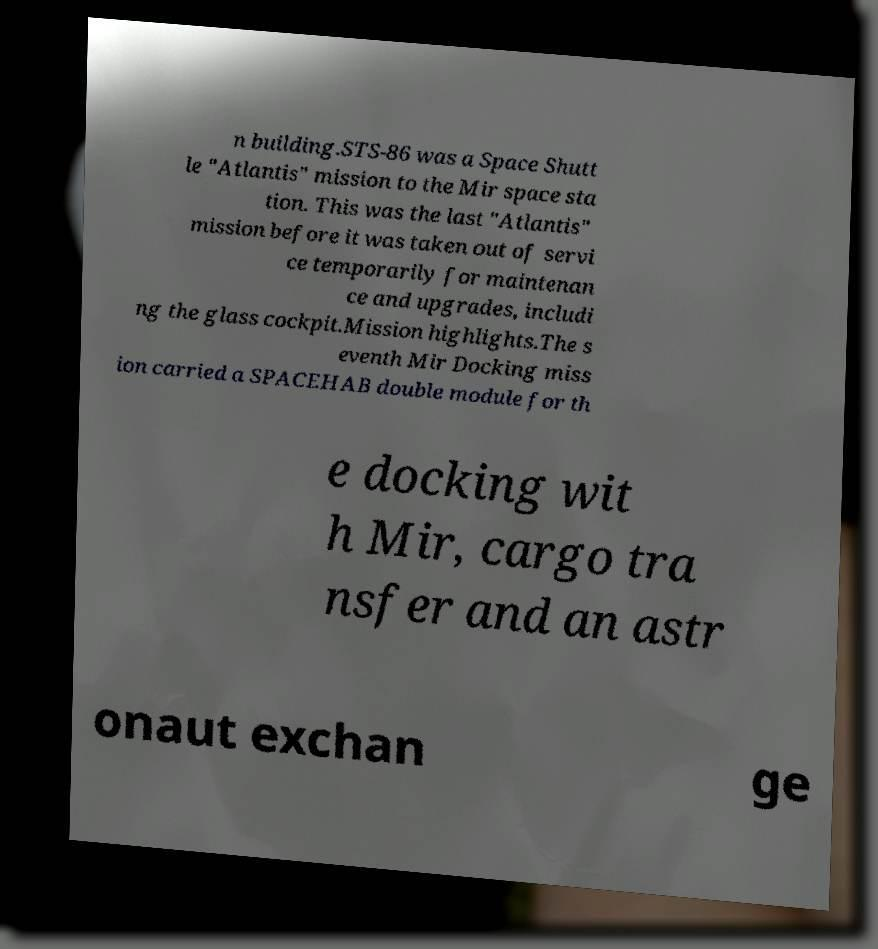Please identify and transcribe the text found in this image. n building.STS-86 was a Space Shutt le "Atlantis" mission to the Mir space sta tion. This was the last "Atlantis" mission before it was taken out of servi ce temporarily for maintenan ce and upgrades, includi ng the glass cockpit.Mission highlights.The s eventh Mir Docking miss ion carried a SPACEHAB double module for th e docking wit h Mir, cargo tra nsfer and an astr onaut exchan ge 